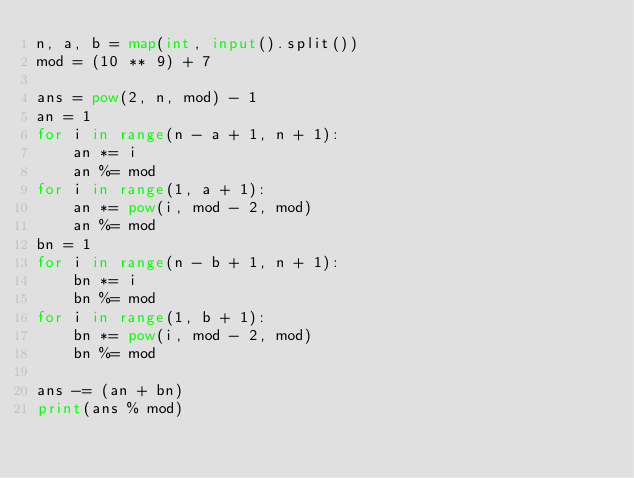<code> <loc_0><loc_0><loc_500><loc_500><_Python_>n, a, b = map(int, input().split())
mod = (10 ** 9) + 7

ans = pow(2, n, mod) - 1
an = 1
for i in range(n - a + 1, n + 1):
    an *= i
    an %= mod
for i in range(1, a + 1):
    an *= pow(i, mod - 2, mod)
    an %= mod
bn = 1
for i in range(n - b + 1, n + 1):
    bn *= i
    bn %= mod
for i in range(1, b + 1):
    bn *= pow(i, mod - 2, mod)
    bn %= mod

ans -= (an + bn)
print(ans % mod)
</code> 